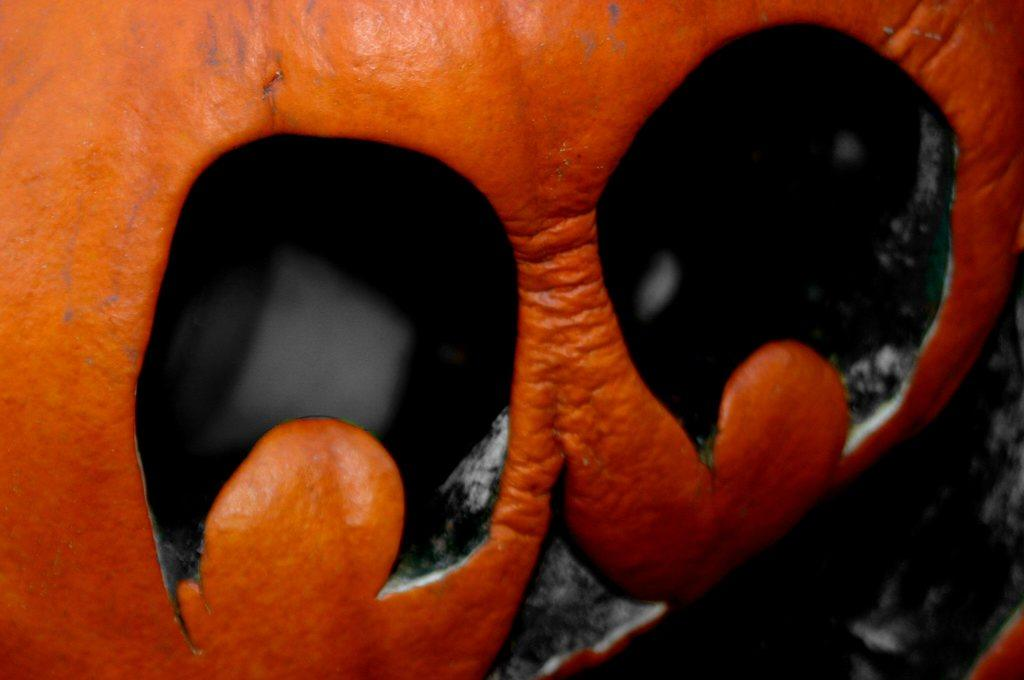What object can be seen in the image? There is an orange peel in the image. What can be observed about the background of the image? The background of the image is dark. How many visitors are present in the image? There are no visitors present in the image; it only features an orange peel. What process is being depicted in the image? There is no process being depicted in the image; it only shows an orange peel and a dark background. 